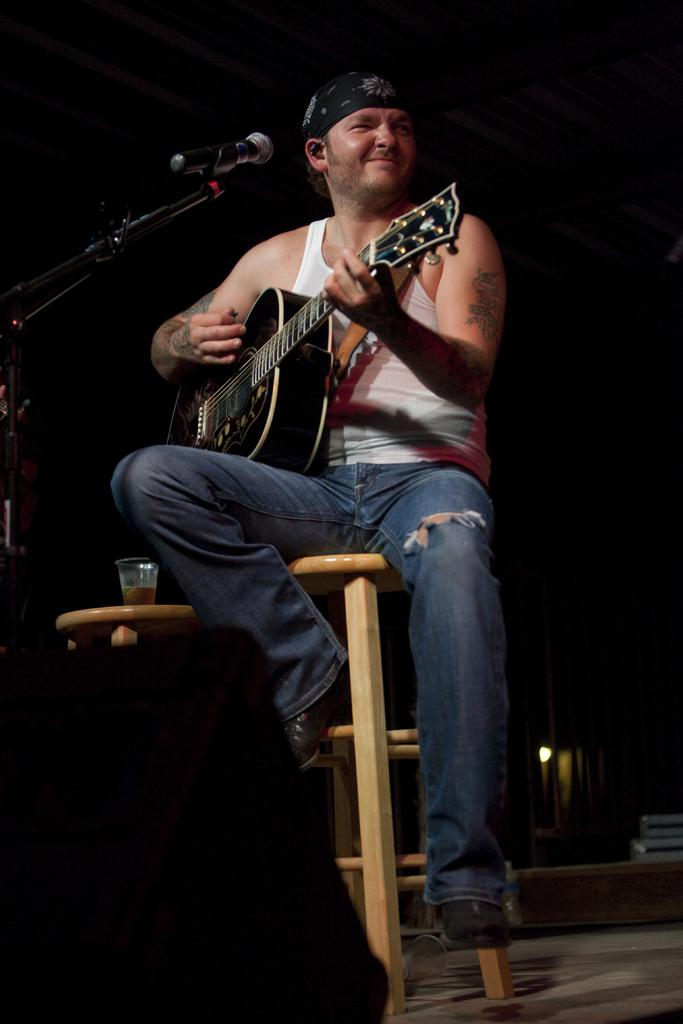What is the person in the image doing? The person is sitting on a stool and playing a guitar. What is the person's facial expression in the image? The person is smiling. What object is in front of the person? There is a microphone in front of the person. What type of theory is the person discussing while playing the guitar in the image? There is no indication in the image that the person is discussing any theory while playing the guitar. 